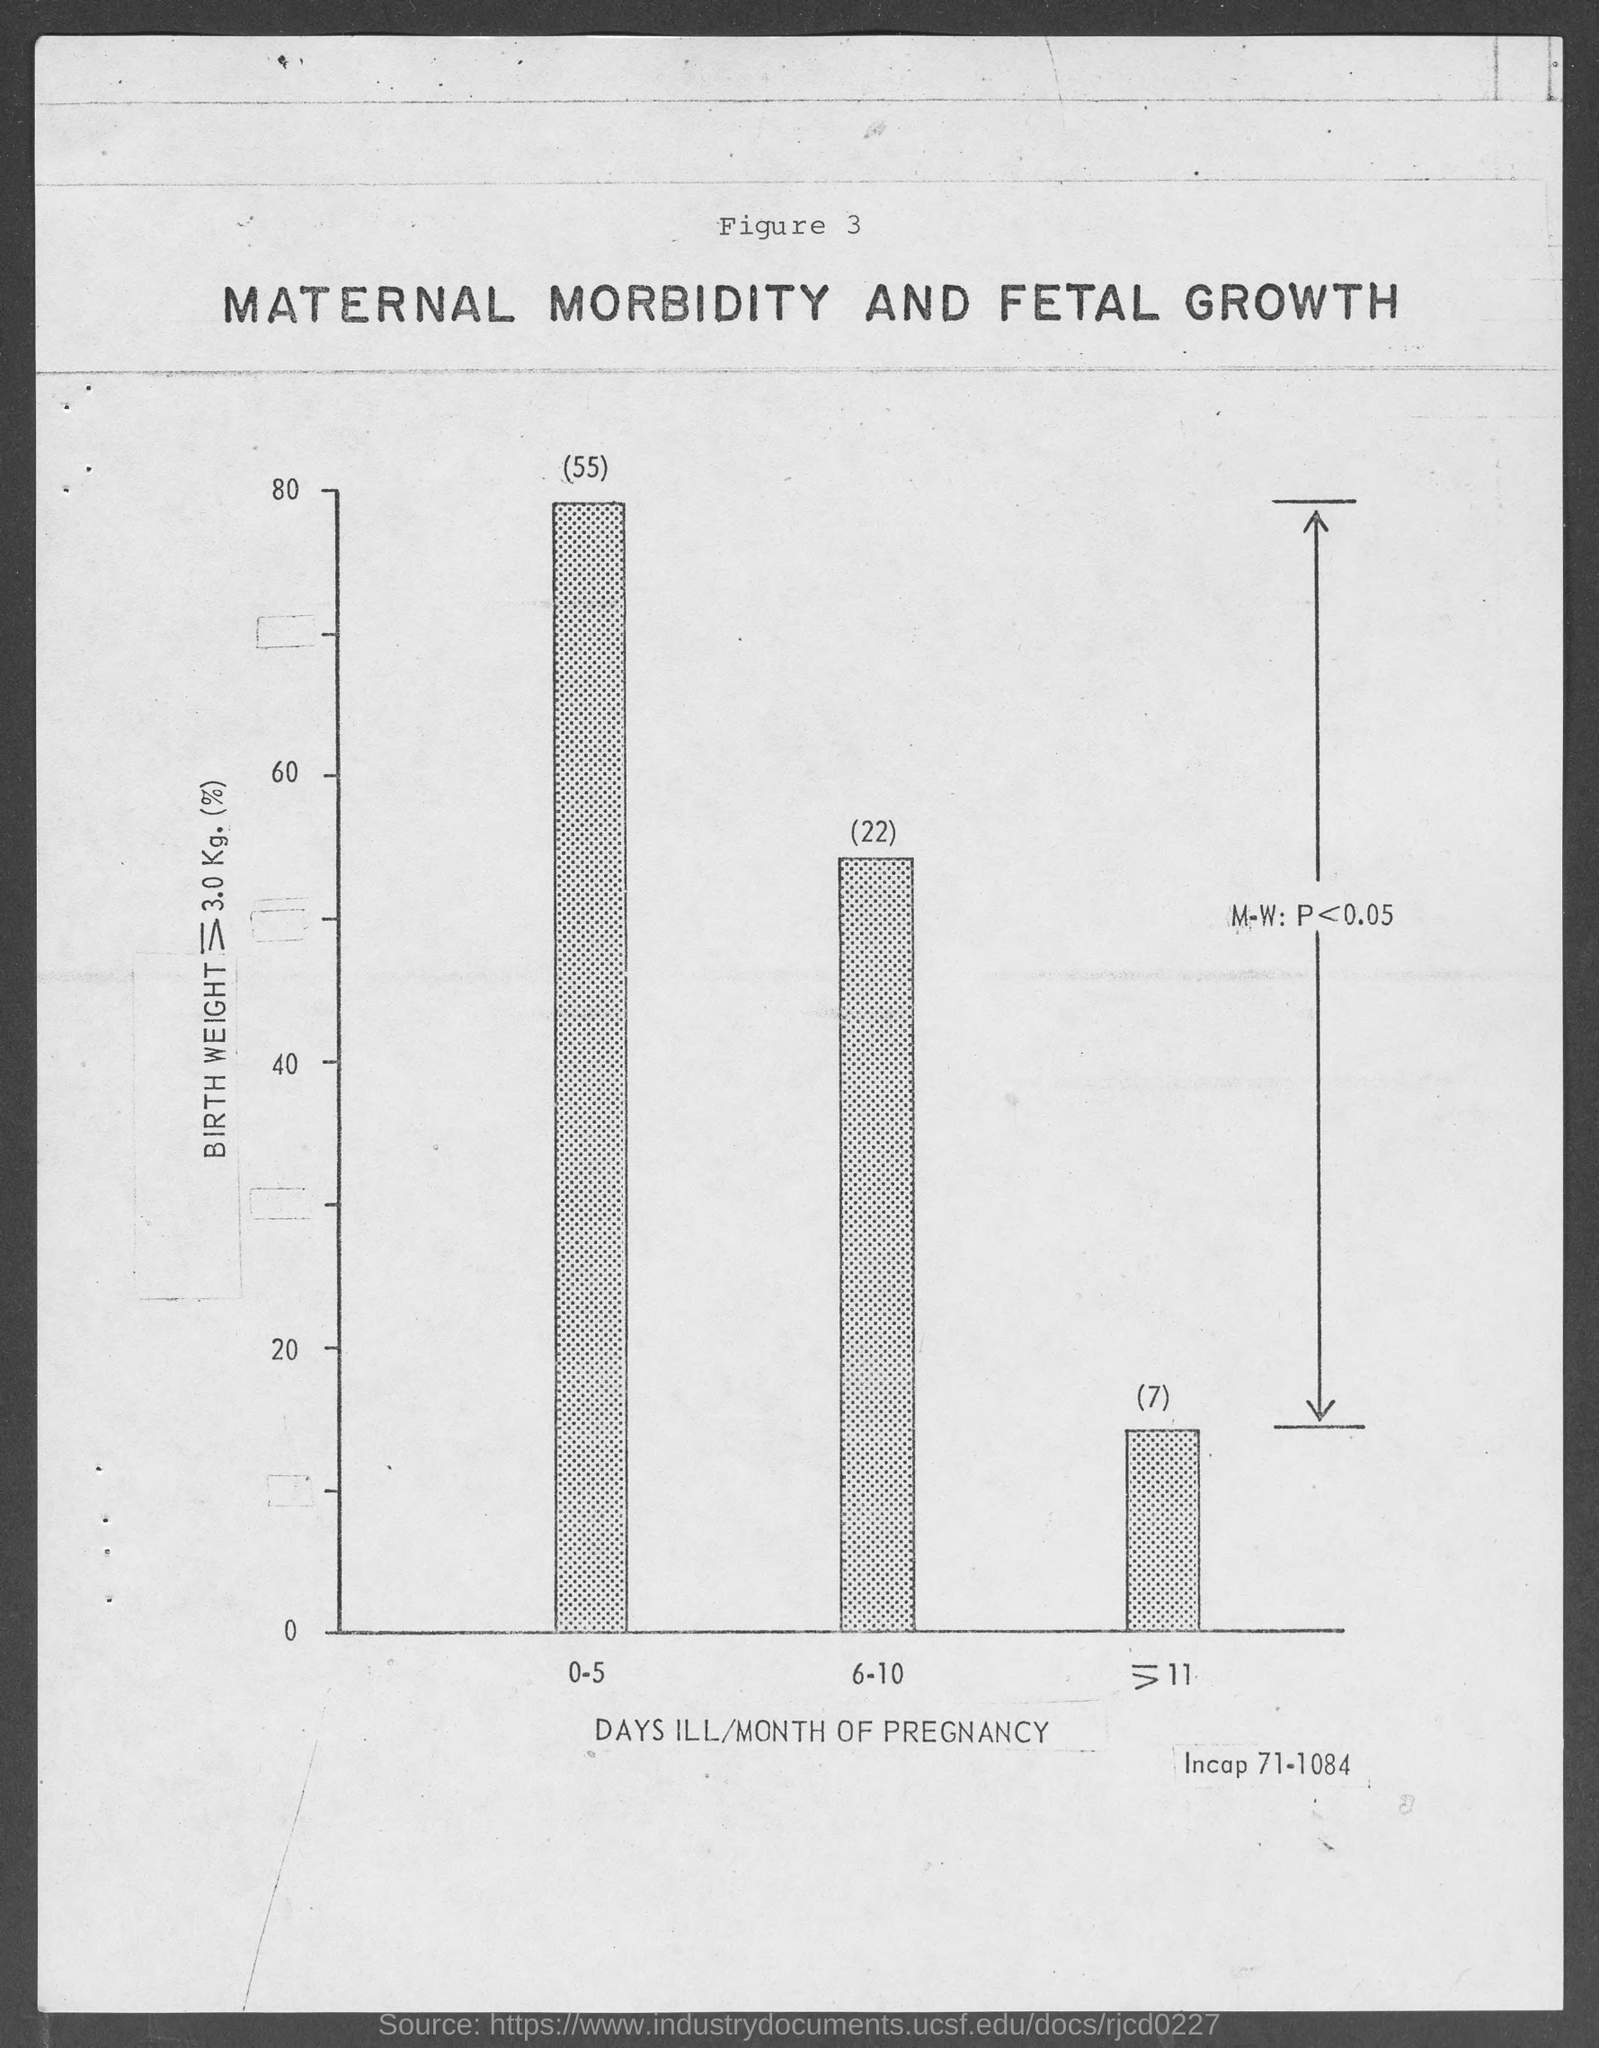What does the X-axis of the graph represent?
Your response must be concise. Days ill/month of pregnancy. 